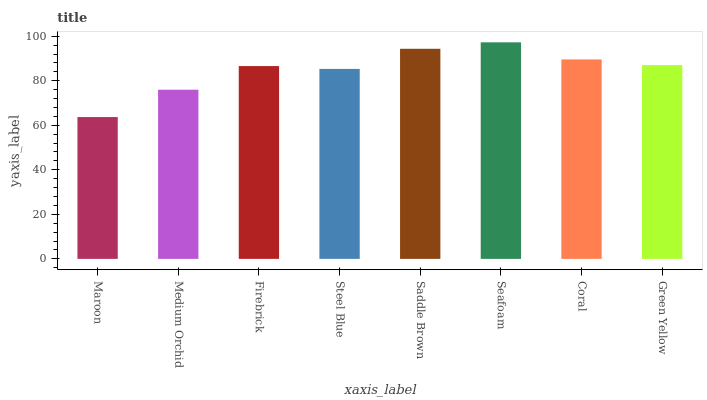Is Maroon the minimum?
Answer yes or no. Yes. Is Seafoam the maximum?
Answer yes or no. Yes. Is Medium Orchid the minimum?
Answer yes or no. No. Is Medium Orchid the maximum?
Answer yes or no. No. Is Medium Orchid greater than Maroon?
Answer yes or no. Yes. Is Maroon less than Medium Orchid?
Answer yes or no. Yes. Is Maroon greater than Medium Orchid?
Answer yes or no. No. Is Medium Orchid less than Maroon?
Answer yes or no. No. Is Green Yellow the high median?
Answer yes or no. Yes. Is Firebrick the low median?
Answer yes or no. Yes. Is Seafoam the high median?
Answer yes or no. No. Is Maroon the low median?
Answer yes or no. No. 